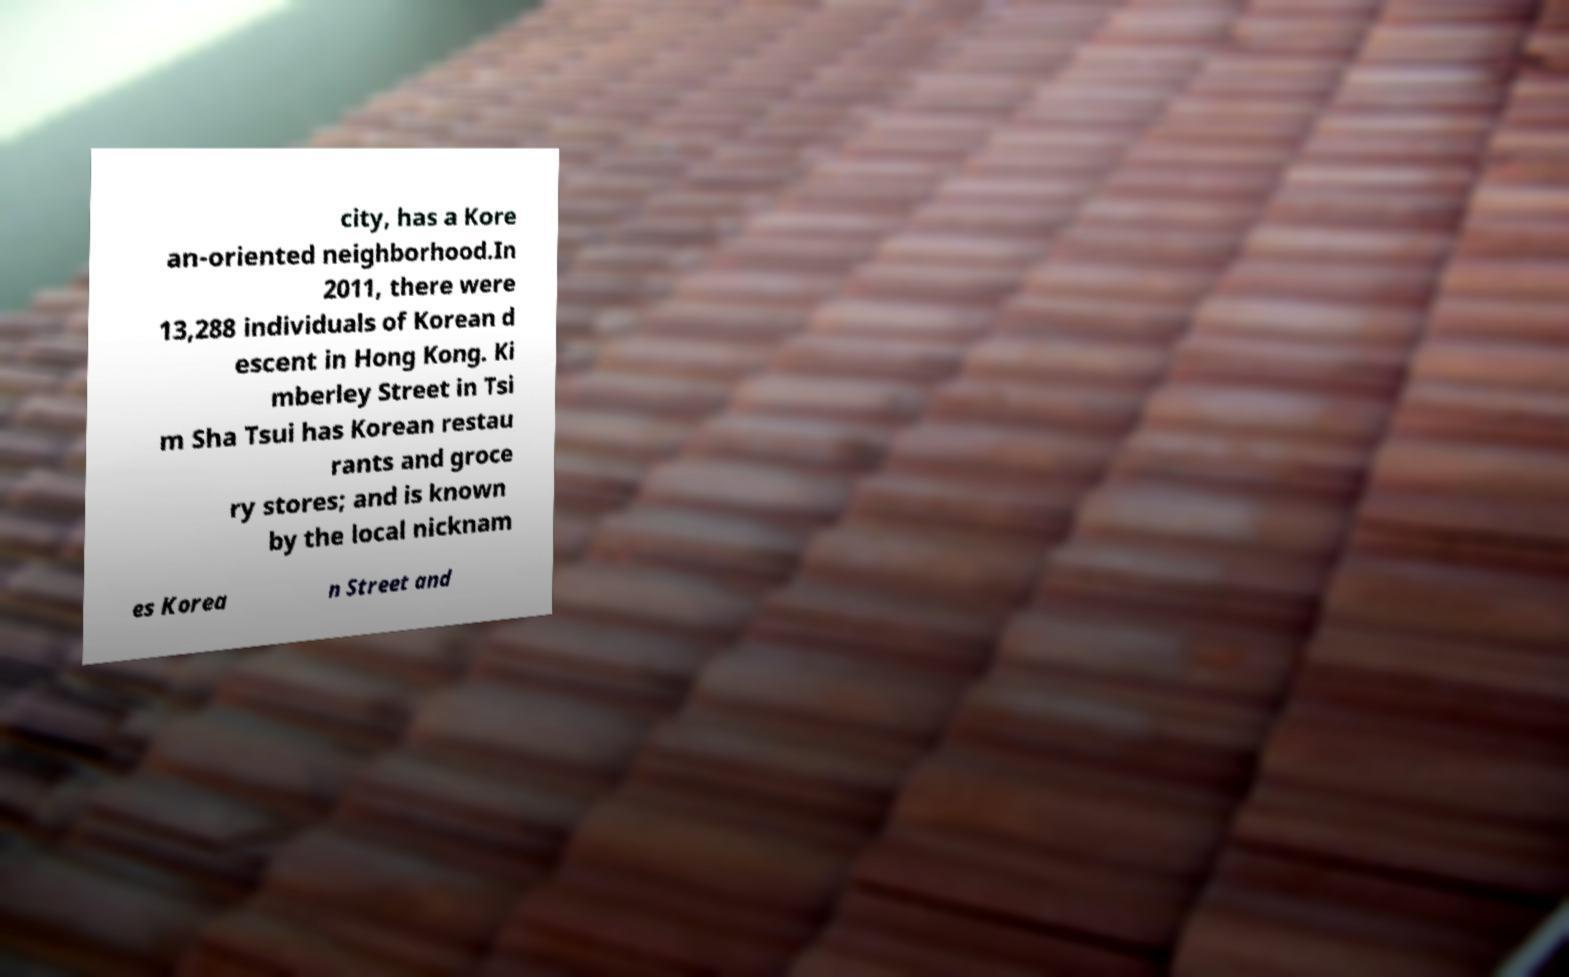What messages or text are displayed in this image? I need them in a readable, typed format. city, has a Kore an-oriented neighborhood.In 2011, there were 13,288 individuals of Korean d escent in Hong Kong. Ki mberley Street in Tsi m Sha Tsui has Korean restau rants and groce ry stores; and is known by the local nicknam es Korea n Street and 